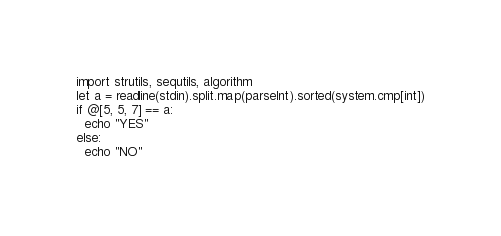Convert code to text. <code><loc_0><loc_0><loc_500><loc_500><_Nim_>import strutils, sequtils, algorithm
let a = readline(stdin).split.map(parseInt).sorted(system.cmp[int])
if @[5, 5, 7] == a:
  echo "YES"
else:
  echo "NO"
</code> 